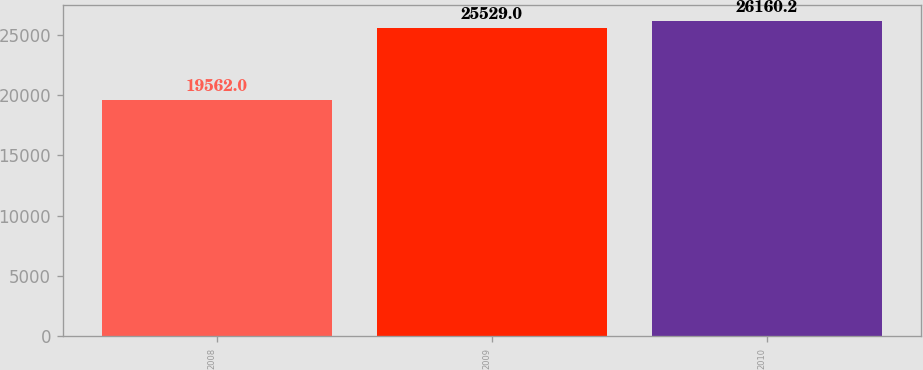Convert chart. <chart><loc_0><loc_0><loc_500><loc_500><bar_chart><fcel>2008<fcel>2009<fcel>2010<nl><fcel>19562<fcel>25529<fcel>26160.2<nl></chart> 